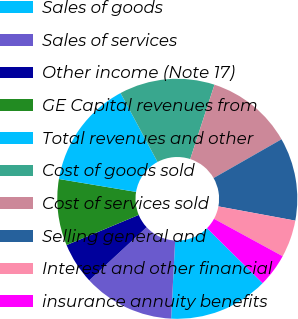Convert chart to OTSL. <chart><loc_0><loc_0><loc_500><loc_500><pie_chart><fcel>Sales of goods<fcel>Sales of services<fcel>Other income (Note 17)<fcel>GE Capital revenues from<fcel>Total revenues and other<fcel>Cost of goods sold<fcel>Cost of services sold<fcel>Selling general and<fcel>Interest and other financial<fcel>insurance annuity benefits<nl><fcel>13.41%<fcel>12.29%<fcel>5.59%<fcel>8.94%<fcel>14.53%<fcel>12.85%<fcel>11.73%<fcel>11.17%<fcel>5.03%<fcel>4.47%<nl></chart> 